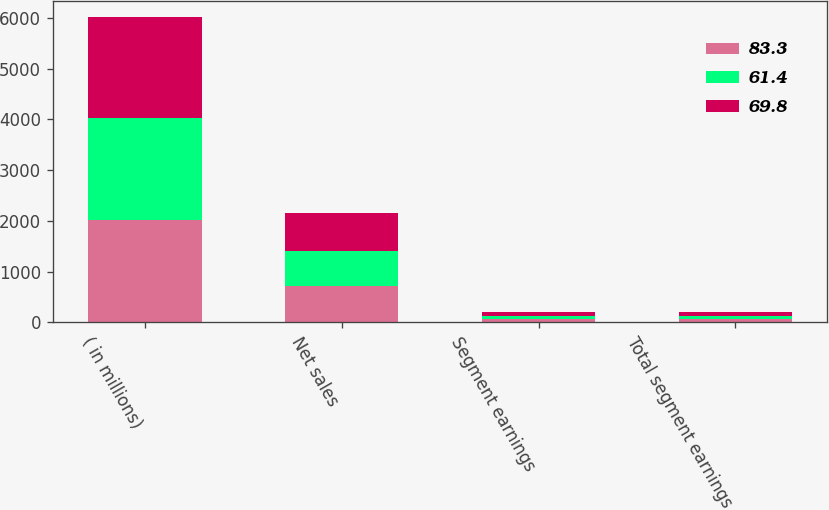Convert chart to OTSL. <chart><loc_0><loc_0><loc_500><loc_500><stacked_bar_chart><ecel><fcel>( in millions)<fcel>Net sales<fcel>Segment earnings<fcel>Total segment earnings<nl><fcel>83.3<fcel>2010<fcel>713.7<fcel>69.8<fcel>69.8<nl><fcel>61.4<fcel>2009<fcel>689.2<fcel>61.4<fcel>61.4<nl><fcel>69.8<fcel>2008<fcel>746.5<fcel>76.2<fcel>83.3<nl></chart> 